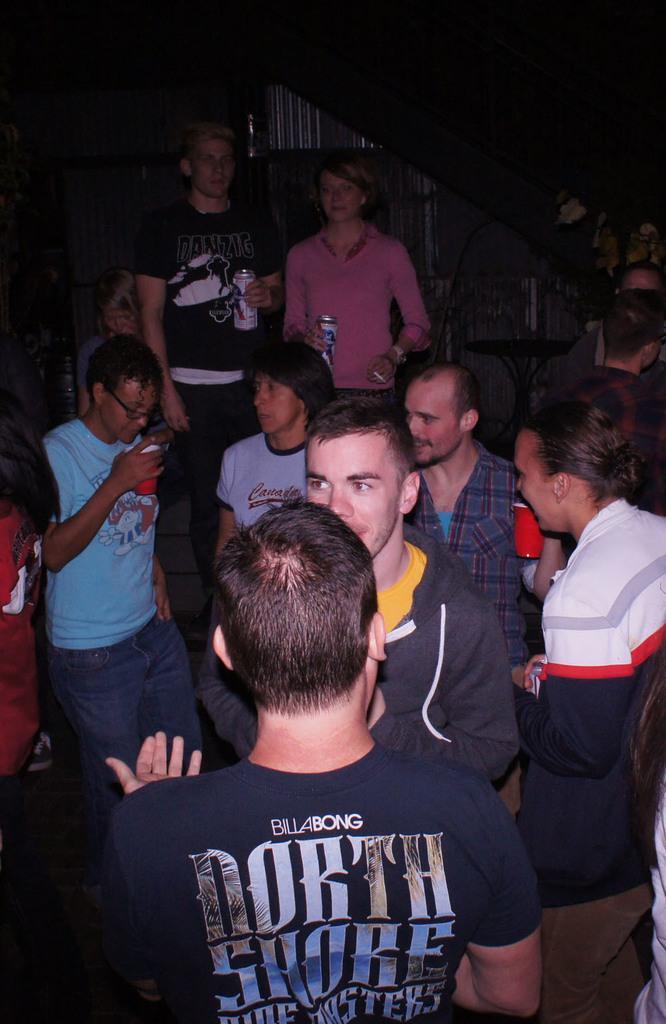In one or two sentences, can you explain what this image depicts? This picture describes about group of people, few people are holding bottles in their hands. 